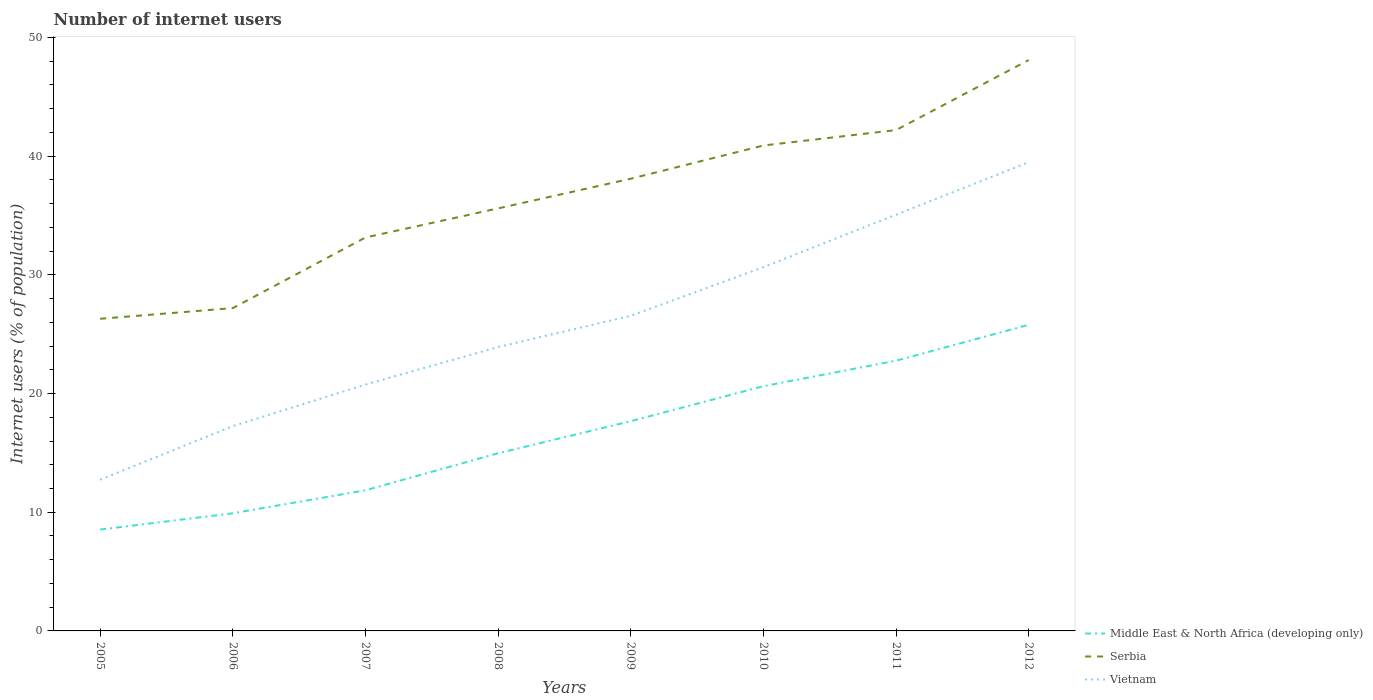Across all years, what is the maximum number of internet users in Middle East & North Africa (developing only)?
Your answer should be compact. 8.54. What is the total number of internet users in Middle East & North Africa (developing only) in the graph?
Offer a very short reply. -17.25. What is the difference between the highest and the second highest number of internet users in Middle East & North Africa (developing only)?
Your answer should be very brief. 17.25. What is the difference between the highest and the lowest number of internet users in Vietnam?
Provide a short and direct response. 4. Is the number of internet users in Vietnam strictly greater than the number of internet users in Middle East & North Africa (developing only) over the years?
Keep it short and to the point. No. How many lines are there?
Your answer should be compact. 3. How many years are there in the graph?
Ensure brevity in your answer.  8. What is the difference between two consecutive major ticks on the Y-axis?
Provide a short and direct response. 10. Does the graph contain any zero values?
Provide a short and direct response. No. Does the graph contain grids?
Give a very brief answer. No. What is the title of the graph?
Ensure brevity in your answer.  Number of internet users. Does "Bulgaria" appear as one of the legend labels in the graph?
Provide a succinct answer. No. What is the label or title of the X-axis?
Keep it short and to the point. Years. What is the label or title of the Y-axis?
Ensure brevity in your answer.  Internet users (% of population). What is the Internet users (% of population) of Middle East & North Africa (developing only) in 2005?
Your answer should be very brief. 8.54. What is the Internet users (% of population) in Serbia in 2005?
Provide a short and direct response. 26.3. What is the Internet users (% of population) in Vietnam in 2005?
Your answer should be compact. 12.74. What is the Internet users (% of population) of Middle East & North Africa (developing only) in 2006?
Keep it short and to the point. 9.91. What is the Internet users (% of population) in Serbia in 2006?
Your answer should be compact. 27.2. What is the Internet users (% of population) of Vietnam in 2006?
Provide a short and direct response. 17.25. What is the Internet users (% of population) in Middle East & North Africa (developing only) in 2007?
Offer a terse response. 11.85. What is the Internet users (% of population) of Serbia in 2007?
Offer a terse response. 33.15. What is the Internet users (% of population) of Vietnam in 2007?
Keep it short and to the point. 20.76. What is the Internet users (% of population) in Middle East & North Africa (developing only) in 2008?
Your response must be concise. 14.97. What is the Internet users (% of population) in Serbia in 2008?
Your response must be concise. 35.6. What is the Internet users (% of population) in Vietnam in 2008?
Your answer should be very brief. 23.92. What is the Internet users (% of population) in Middle East & North Africa (developing only) in 2009?
Ensure brevity in your answer.  17.67. What is the Internet users (% of population) in Serbia in 2009?
Offer a terse response. 38.1. What is the Internet users (% of population) of Vietnam in 2009?
Offer a terse response. 26.55. What is the Internet users (% of population) of Middle East & North Africa (developing only) in 2010?
Provide a short and direct response. 20.62. What is the Internet users (% of population) of Serbia in 2010?
Your response must be concise. 40.9. What is the Internet users (% of population) of Vietnam in 2010?
Your answer should be very brief. 30.65. What is the Internet users (% of population) in Middle East & North Africa (developing only) in 2011?
Offer a very short reply. 22.77. What is the Internet users (% of population) of Serbia in 2011?
Provide a short and direct response. 42.2. What is the Internet users (% of population) of Vietnam in 2011?
Offer a very short reply. 35.07. What is the Internet users (% of population) in Middle East & North Africa (developing only) in 2012?
Offer a terse response. 25.79. What is the Internet users (% of population) of Serbia in 2012?
Give a very brief answer. 48.1. What is the Internet users (% of population) in Vietnam in 2012?
Your answer should be very brief. 39.49. Across all years, what is the maximum Internet users (% of population) in Middle East & North Africa (developing only)?
Your answer should be very brief. 25.79. Across all years, what is the maximum Internet users (% of population) in Serbia?
Offer a terse response. 48.1. Across all years, what is the maximum Internet users (% of population) of Vietnam?
Provide a short and direct response. 39.49. Across all years, what is the minimum Internet users (% of population) in Middle East & North Africa (developing only)?
Your answer should be compact. 8.54. Across all years, what is the minimum Internet users (% of population) of Serbia?
Provide a short and direct response. 26.3. Across all years, what is the minimum Internet users (% of population) of Vietnam?
Provide a short and direct response. 12.74. What is the total Internet users (% of population) of Middle East & North Africa (developing only) in the graph?
Give a very brief answer. 132.12. What is the total Internet users (% of population) of Serbia in the graph?
Your answer should be very brief. 291.55. What is the total Internet users (% of population) in Vietnam in the graph?
Offer a terse response. 206.43. What is the difference between the Internet users (% of population) of Middle East & North Africa (developing only) in 2005 and that in 2006?
Offer a very short reply. -1.37. What is the difference between the Internet users (% of population) of Serbia in 2005 and that in 2006?
Your answer should be very brief. -0.9. What is the difference between the Internet users (% of population) in Vietnam in 2005 and that in 2006?
Keep it short and to the point. -4.51. What is the difference between the Internet users (% of population) in Middle East & North Africa (developing only) in 2005 and that in 2007?
Keep it short and to the point. -3.31. What is the difference between the Internet users (% of population) in Serbia in 2005 and that in 2007?
Provide a short and direct response. -6.85. What is the difference between the Internet users (% of population) of Vietnam in 2005 and that in 2007?
Keep it short and to the point. -8.02. What is the difference between the Internet users (% of population) in Middle East & North Africa (developing only) in 2005 and that in 2008?
Your answer should be compact. -6.43. What is the difference between the Internet users (% of population) of Serbia in 2005 and that in 2008?
Make the answer very short. -9.3. What is the difference between the Internet users (% of population) of Vietnam in 2005 and that in 2008?
Ensure brevity in your answer.  -11.18. What is the difference between the Internet users (% of population) of Middle East & North Africa (developing only) in 2005 and that in 2009?
Offer a very short reply. -9.13. What is the difference between the Internet users (% of population) in Serbia in 2005 and that in 2009?
Ensure brevity in your answer.  -11.8. What is the difference between the Internet users (% of population) in Vietnam in 2005 and that in 2009?
Make the answer very short. -13.81. What is the difference between the Internet users (% of population) of Middle East & North Africa (developing only) in 2005 and that in 2010?
Keep it short and to the point. -12.08. What is the difference between the Internet users (% of population) of Serbia in 2005 and that in 2010?
Offer a very short reply. -14.6. What is the difference between the Internet users (% of population) in Vietnam in 2005 and that in 2010?
Your answer should be very brief. -17.91. What is the difference between the Internet users (% of population) in Middle East & North Africa (developing only) in 2005 and that in 2011?
Your answer should be very brief. -14.23. What is the difference between the Internet users (% of population) of Serbia in 2005 and that in 2011?
Offer a very short reply. -15.9. What is the difference between the Internet users (% of population) of Vietnam in 2005 and that in 2011?
Your answer should be very brief. -22.33. What is the difference between the Internet users (% of population) of Middle East & North Africa (developing only) in 2005 and that in 2012?
Your answer should be compact. -17.25. What is the difference between the Internet users (% of population) of Serbia in 2005 and that in 2012?
Offer a terse response. -21.8. What is the difference between the Internet users (% of population) of Vietnam in 2005 and that in 2012?
Offer a very short reply. -26.75. What is the difference between the Internet users (% of population) of Middle East & North Africa (developing only) in 2006 and that in 2007?
Offer a terse response. -1.94. What is the difference between the Internet users (% of population) of Serbia in 2006 and that in 2007?
Provide a short and direct response. -5.95. What is the difference between the Internet users (% of population) in Vietnam in 2006 and that in 2007?
Your response must be concise. -3.5. What is the difference between the Internet users (% of population) in Middle East & North Africa (developing only) in 2006 and that in 2008?
Keep it short and to the point. -5.05. What is the difference between the Internet users (% of population) in Serbia in 2006 and that in 2008?
Offer a very short reply. -8.4. What is the difference between the Internet users (% of population) in Vietnam in 2006 and that in 2008?
Your answer should be compact. -6.67. What is the difference between the Internet users (% of population) of Middle East & North Africa (developing only) in 2006 and that in 2009?
Make the answer very short. -7.76. What is the difference between the Internet users (% of population) in Serbia in 2006 and that in 2009?
Make the answer very short. -10.9. What is the difference between the Internet users (% of population) of Vietnam in 2006 and that in 2009?
Provide a short and direct response. -9.3. What is the difference between the Internet users (% of population) in Middle East & North Africa (developing only) in 2006 and that in 2010?
Offer a terse response. -10.71. What is the difference between the Internet users (% of population) in Serbia in 2006 and that in 2010?
Your answer should be very brief. -13.7. What is the difference between the Internet users (% of population) of Vietnam in 2006 and that in 2010?
Your answer should be compact. -13.4. What is the difference between the Internet users (% of population) in Middle East & North Africa (developing only) in 2006 and that in 2011?
Ensure brevity in your answer.  -12.85. What is the difference between the Internet users (% of population) of Vietnam in 2006 and that in 2011?
Your answer should be very brief. -17.82. What is the difference between the Internet users (% of population) in Middle East & North Africa (developing only) in 2006 and that in 2012?
Make the answer very short. -15.88. What is the difference between the Internet users (% of population) in Serbia in 2006 and that in 2012?
Offer a very short reply. -20.9. What is the difference between the Internet users (% of population) in Vietnam in 2006 and that in 2012?
Give a very brief answer. -22.24. What is the difference between the Internet users (% of population) in Middle East & North Africa (developing only) in 2007 and that in 2008?
Give a very brief answer. -3.12. What is the difference between the Internet users (% of population) of Serbia in 2007 and that in 2008?
Give a very brief answer. -2.45. What is the difference between the Internet users (% of population) in Vietnam in 2007 and that in 2008?
Your response must be concise. -3.16. What is the difference between the Internet users (% of population) of Middle East & North Africa (developing only) in 2007 and that in 2009?
Provide a short and direct response. -5.82. What is the difference between the Internet users (% of population) of Serbia in 2007 and that in 2009?
Offer a terse response. -4.95. What is the difference between the Internet users (% of population) of Vietnam in 2007 and that in 2009?
Give a very brief answer. -5.79. What is the difference between the Internet users (% of population) in Middle East & North Africa (developing only) in 2007 and that in 2010?
Make the answer very short. -8.77. What is the difference between the Internet users (% of population) in Serbia in 2007 and that in 2010?
Your answer should be very brief. -7.75. What is the difference between the Internet users (% of population) in Vietnam in 2007 and that in 2010?
Your response must be concise. -9.89. What is the difference between the Internet users (% of population) of Middle East & North Africa (developing only) in 2007 and that in 2011?
Keep it short and to the point. -10.92. What is the difference between the Internet users (% of population) in Serbia in 2007 and that in 2011?
Your answer should be compact. -9.05. What is the difference between the Internet users (% of population) of Vietnam in 2007 and that in 2011?
Your response must be concise. -14.31. What is the difference between the Internet users (% of population) in Middle East & North Africa (developing only) in 2007 and that in 2012?
Offer a terse response. -13.94. What is the difference between the Internet users (% of population) in Serbia in 2007 and that in 2012?
Give a very brief answer. -14.95. What is the difference between the Internet users (% of population) of Vietnam in 2007 and that in 2012?
Provide a short and direct response. -18.73. What is the difference between the Internet users (% of population) in Middle East & North Africa (developing only) in 2008 and that in 2009?
Your answer should be very brief. -2.7. What is the difference between the Internet users (% of population) in Vietnam in 2008 and that in 2009?
Your answer should be compact. -2.63. What is the difference between the Internet users (% of population) in Middle East & North Africa (developing only) in 2008 and that in 2010?
Offer a very short reply. -5.65. What is the difference between the Internet users (% of population) of Vietnam in 2008 and that in 2010?
Ensure brevity in your answer.  -6.73. What is the difference between the Internet users (% of population) in Middle East & North Africa (developing only) in 2008 and that in 2011?
Ensure brevity in your answer.  -7.8. What is the difference between the Internet users (% of population) in Serbia in 2008 and that in 2011?
Make the answer very short. -6.6. What is the difference between the Internet users (% of population) of Vietnam in 2008 and that in 2011?
Offer a terse response. -11.15. What is the difference between the Internet users (% of population) in Middle East & North Africa (developing only) in 2008 and that in 2012?
Provide a succinct answer. -10.83. What is the difference between the Internet users (% of population) of Vietnam in 2008 and that in 2012?
Your answer should be compact. -15.57. What is the difference between the Internet users (% of population) in Middle East & North Africa (developing only) in 2009 and that in 2010?
Your answer should be compact. -2.95. What is the difference between the Internet users (% of population) of Middle East & North Africa (developing only) in 2009 and that in 2011?
Your answer should be very brief. -5.1. What is the difference between the Internet users (% of population) in Vietnam in 2009 and that in 2011?
Ensure brevity in your answer.  -8.52. What is the difference between the Internet users (% of population) in Middle East & North Africa (developing only) in 2009 and that in 2012?
Give a very brief answer. -8.12. What is the difference between the Internet users (% of population) in Serbia in 2009 and that in 2012?
Provide a short and direct response. -10. What is the difference between the Internet users (% of population) in Vietnam in 2009 and that in 2012?
Provide a short and direct response. -12.94. What is the difference between the Internet users (% of population) of Middle East & North Africa (developing only) in 2010 and that in 2011?
Make the answer very short. -2.15. What is the difference between the Internet users (% of population) in Vietnam in 2010 and that in 2011?
Your answer should be very brief. -4.42. What is the difference between the Internet users (% of population) in Middle East & North Africa (developing only) in 2010 and that in 2012?
Offer a very short reply. -5.17. What is the difference between the Internet users (% of population) in Serbia in 2010 and that in 2012?
Your response must be concise. -7.2. What is the difference between the Internet users (% of population) in Vietnam in 2010 and that in 2012?
Ensure brevity in your answer.  -8.84. What is the difference between the Internet users (% of population) of Middle East & North Africa (developing only) in 2011 and that in 2012?
Your answer should be very brief. -3.03. What is the difference between the Internet users (% of population) in Serbia in 2011 and that in 2012?
Offer a terse response. -5.9. What is the difference between the Internet users (% of population) of Vietnam in 2011 and that in 2012?
Your response must be concise. -4.42. What is the difference between the Internet users (% of population) in Middle East & North Africa (developing only) in 2005 and the Internet users (% of population) in Serbia in 2006?
Offer a very short reply. -18.66. What is the difference between the Internet users (% of population) in Middle East & North Africa (developing only) in 2005 and the Internet users (% of population) in Vietnam in 2006?
Ensure brevity in your answer.  -8.72. What is the difference between the Internet users (% of population) in Serbia in 2005 and the Internet users (% of population) in Vietnam in 2006?
Your response must be concise. 9.05. What is the difference between the Internet users (% of population) in Middle East & North Africa (developing only) in 2005 and the Internet users (% of population) in Serbia in 2007?
Provide a succinct answer. -24.61. What is the difference between the Internet users (% of population) of Middle East & North Africa (developing only) in 2005 and the Internet users (% of population) of Vietnam in 2007?
Give a very brief answer. -12.22. What is the difference between the Internet users (% of population) of Serbia in 2005 and the Internet users (% of population) of Vietnam in 2007?
Provide a succinct answer. 5.54. What is the difference between the Internet users (% of population) of Middle East & North Africa (developing only) in 2005 and the Internet users (% of population) of Serbia in 2008?
Provide a succinct answer. -27.06. What is the difference between the Internet users (% of population) in Middle East & North Africa (developing only) in 2005 and the Internet users (% of population) in Vietnam in 2008?
Give a very brief answer. -15.38. What is the difference between the Internet users (% of population) in Serbia in 2005 and the Internet users (% of population) in Vietnam in 2008?
Your response must be concise. 2.38. What is the difference between the Internet users (% of population) of Middle East & North Africa (developing only) in 2005 and the Internet users (% of population) of Serbia in 2009?
Offer a very short reply. -29.56. What is the difference between the Internet users (% of population) of Middle East & North Africa (developing only) in 2005 and the Internet users (% of population) of Vietnam in 2009?
Provide a short and direct response. -18.01. What is the difference between the Internet users (% of population) in Serbia in 2005 and the Internet users (% of population) in Vietnam in 2009?
Give a very brief answer. -0.25. What is the difference between the Internet users (% of population) in Middle East & North Africa (developing only) in 2005 and the Internet users (% of population) in Serbia in 2010?
Make the answer very short. -32.36. What is the difference between the Internet users (% of population) in Middle East & North Africa (developing only) in 2005 and the Internet users (% of population) in Vietnam in 2010?
Make the answer very short. -22.11. What is the difference between the Internet users (% of population) in Serbia in 2005 and the Internet users (% of population) in Vietnam in 2010?
Ensure brevity in your answer.  -4.35. What is the difference between the Internet users (% of population) of Middle East & North Africa (developing only) in 2005 and the Internet users (% of population) of Serbia in 2011?
Give a very brief answer. -33.66. What is the difference between the Internet users (% of population) in Middle East & North Africa (developing only) in 2005 and the Internet users (% of population) in Vietnam in 2011?
Offer a very short reply. -26.53. What is the difference between the Internet users (% of population) of Serbia in 2005 and the Internet users (% of population) of Vietnam in 2011?
Ensure brevity in your answer.  -8.77. What is the difference between the Internet users (% of population) in Middle East & North Africa (developing only) in 2005 and the Internet users (% of population) in Serbia in 2012?
Your answer should be very brief. -39.56. What is the difference between the Internet users (% of population) in Middle East & North Africa (developing only) in 2005 and the Internet users (% of population) in Vietnam in 2012?
Your response must be concise. -30.95. What is the difference between the Internet users (% of population) in Serbia in 2005 and the Internet users (% of population) in Vietnam in 2012?
Keep it short and to the point. -13.19. What is the difference between the Internet users (% of population) in Middle East & North Africa (developing only) in 2006 and the Internet users (% of population) in Serbia in 2007?
Provide a succinct answer. -23.24. What is the difference between the Internet users (% of population) in Middle East & North Africa (developing only) in 2006 and the Internet users (% of population) in Vietnam in 2007?
Your response must be concise. -10.84. What is the difference between the Internet users (% of population) in Serbia in 2006 and the Internet users (% of population) in Vietnam in 2007?
Offer a very short reply. 6.44. What is the difference between the Internet users (% of population) of Middle East & North Africa (developing only) in 2006 and the Internet users (% of population) of Serbia in 2008?
Your response must be concise. -25.69. What is the difference between the Internet users (% of population) in Middle East & North Africa (developing only) in 2006 and the Internet users (% of population) in Vietnam in 2008?
Your answer should be compact. -14.01. What is the difference between the Internet users (% of population) of Serbia in 2006 and the Internet users (% of population) of Vietnam in 2008?
Give a very brief answer. 3.28. What is the difference between the Internet users (% of population) in Middle East & North Africa (developing only) in 2006 and the Internet users (% of population) in Serbia in 2009?
Ensure brevity in your answer.  -28.19. What is the difference between the Internet users (% of population) of Middle East & North Africa (developing only) in 2006 and the Internet users (% of population) of Vietnam in 2009?
Keep it short and to the point. -16.64. What is the difference between the Internet users (% of population) in Serbia in 2006 and the Internet users (% of population) in Vietnam in 2009?
Ensure brevity in your answer.  0.65. What is the difference between the Internet users (% of population) in Middle East & North Africa (developing only) in 2006 and the Internet users (% of population) in Serbia in 2010?
Offer a terse response. -30.99. What is the difference between the Internet users (% of population) of Middle East & North Africa (developing only) in 2006 and the Internet users (% of population) of Vietnam in 2010?
Keep it short and to the point. -20.74. What is the difference between the Internet users (% of population) of Serbia in 2006 and the Internet users (% of population) of Vietnam in 2010?
Your answer should be very brief. -3.45. What is the difference between the Internet users (% of population) in Middle East & North Africa (developing only) in 2006 and the Internet users (% of population) in Serbia in 2011?
Offer a very short reply. -32.29. What is the difference between the Internet users (% of population) of Middle East & North Africa (developing only) in 2006 and the Internet users (% of population) of Vietnam in 2011?
Give a very brief answer. -25.16. What is the difference between the Internet users (% of population) of Serbia in 2006 and the Internet users (% of population) of Vietnam in 2011?
Ensure brevity in your answer.  -7.87. What is the difference between the Internet users (% of population) of Middle East & North Africa (developing only) in 2006 and the Internet users (% of population) of Serbia in 2012?
Your answer should be compact. -38.19. What is the difference between the Internet users (% of population) in Middle East & North Africa (developing only) in 2006 and the Internet users (% of population) in Vietnam in 2012?
Provide a succinct answer. -29.58. What is the difference between the Internet users (% of population) of Serbia in 2006 and the Internet users (% of population) of Vietnam in 2012?
Offer a terse response. -12.29. What is the difference between the Internet users (% of population) in Middle East & North Africa (developing only) in 2007 and the Internet users (% of population) in Serbia in 2008?
Provide a succinct answer. -23.75. What is the difference between the Internet users (% of population) in Middle East & North Africa (developing only) in 2007 and the Internet users (% of population) in Vietnam in 2008?
Offer a very short reply. -12.07. What is the difference between the Internet users (% of population) of Serbia in 2007 and the Internet users (% of population) of Vietnam in 2008?
Ensure brevity in your answer.  9.23. What is the difference between the Internet users (% of population) in Middle East & North Africa (developing only) in 2007 and the Internet users (% of population) in Serbia in 2009?
Offer a terse response. -26.25. What is the difference between the Internet users (% of population) of Middle East & North Africa (developing only) in 2007 and the Internet users (% of population) of Vietnam in 2009?
Keep it short and to the point. -14.7. What is the difference between the Internet users (% of population) in Serbia in 2007 and the Internet users (% of population) in Vietnam in 2009?
Offer a terse response. 6.6. What is the difference between the Internet users (% of population) in Middle East & North Africa (developing only) in 2007 and the Internet users (% of population) in Serbia in 2010?
Your answer should be very brief. -29.05. What is the difference between the Internet users (% of population) of Middle East & North Africa (developing only) in 2007 and the Internet users (% of population) of Vietnam in 2010?
Offer a very short reply. -18.8. What is the difference between the Internet users (% of population) of Serbia in 2007 and the Internet users (% of population) of Vietnam in 2010?
Offer a terse response. 2.5. What is the difference between the Internet users (% of population) of Middle East & North Africa (developing only) in 2007 and the Internet users (% of population) of Serbia in 2011?
Offer a very short reply. -30.35. What is the difference between the Internet users (% of population) in Middle East & North Africa (developing only) in 2007 and the Internet users (% of population) in Vietnam in 2011?
Keep it short and to the point. -23.22. What is the difference between the Internet users (% of population) of Serbia in 2007 and the Internet users (% of population) of Vietnam in 2011?
Make the answer very short. -1.92. What is the difference between the Internet users (% of population) in Middle East & North Africa (developing only) in 2007 and the Internet users (% of population) in Serbia in 2012?
Your answer should be compact. -36.25. What is the difference between the Internet users (% of population) of Middle East & North Africa (developing only) in 2007 and the Internet users (% of population) of Vietnam in 2012?
Give a very brief answer. -27.64. What is the difference between the Internet users (% of population) in Serbia in 2007 and the Internet users (% of population) in Vietnam in 2012?
Your response must be concise. -6.34. What is the difference between the Internet users (% of population) of Middle East & North Africa (developing only) in 2008 and the Internet users (% of population) of Serbia in 2009?
Keep it short and to the point. -23.13. What is the difference between the Internet users (% of population) of Middle East & North Africa (developing only) in 2008 and the Internet users (% of population) of Vietnam in 2009?
Provide a short and direct response. -11.58. What is the difference between the Internet users (% of population) of Serbia in 2008 and the Internet users (% of population) of Vietnam in 2009?
Provide a succinct answer. 9.05. What is the difference between the Internet users (% of population) in Middle East & North Africa (developing only) in 2008 and the Internet users (% of population) in Serbia in 2010?
Keep it short and to the point. -25.93. What is the difference between the Internet users (% of population) of Middle East & North Africa (developing only) in 2008 and the Internet users (% of population) of Vietnam in 2010?
Make the answer very short. -15.68. What is the difference between the Internet users (% of population) in Serbia in 2008 and the Internet users (% of population) in Vietnam in 2010?
Offer a very short reply. 4.95. What is the difference between the Internet users (% of population) in Middle East & North Africa (developing only) in 2008 and the Internet users (% of population) in Serbia in 2011?
Offer a terse response. -27.23. What is the difference between the Internet users (% of population) in Middle East & North Africa (developing only) in 2008 and the Internet users (% of population) in Vietnam in 2011?
Keep it short and to the point. -20.1. What is the difference between the Internet users (% of population) of Serbia in 2008 and the Internet users (% of population) of Vietnam in 2011?
Give a very brief answer. 0.53. What is the difference between the Internet users (% of population) of Middle East & North Africa (developing only) in 2008 and the Internet users (% of population) of Serbia in 2012?
Provide a succinct answer. -33.13. What is the difference between the Internet users (% of population) in Middle East & North Africa (developing only) in 2008 and the Internet users (% of population) in Vietnam in 2012?
Ensure brevity in your answer.  -24.52. What is the difference between the Internet users (% of population) of Serbia in 2008 and the Internet users (% of population) of Vietnam in 2012?
Keep it short and to the point. -3.89. What is the difference between the Internet users (% of population) of Middle East & North Africa (developing only) in 2009 and the Internet users (% of population) of Serbia in 2010?
Your response must be concise. -23.23. What is the difference between the Internet users (% of population) of Middle East & North Africa (developing only) in 2009 and the Internet users (% of population) of Vietnam in 2010?
Your response must be concise. -12.98. What is the difference between the Internet users (% of population) in Serbia in 2009 and the Internet users (% of population) in Vietnam in 2010?
Provide a short and direct response. 7.45. What is the difference between the Internet users (% of population) of Middle East & North Africa (developing only) in 2009 and the Internet users (% of population) of Serbia in 2011?
Offer a terse response. -24.53. What is the difference between the Internet users (% of population) in Middle East & North Africa (developing only) in 2009 and the Internet users (% of population) in Vietnam in 2011?
Your answer should be very brief. -17.4. What is the difference between the Internet users (% of population) of Serbia in 2009 and the Internet users (% of population) of Vietnam in 2011?
Ensure brevity in your answer.  3.03. What is the difference between the Internet users (% of population) in Middle East & North Africa (developing only) in 2009 and the Internet users (% of population) in Serbia in 2012?
Give a very brief answer. -30.43. What is the difference between the Internet users (% of population) in Middle East & North Africa (developing only) in 2009 and the Internet users (% of population) in Vietnam in 2012?
Provide a short and direct response. -21.82. What is the difference between the Internet users (% of population) of Serbia in 2009 and the Internet users (% of population) of Vietnam in 2012?
Your answer should be very brief. -1.39. What is the difference between the Internet users (% of population) of Middle East & North Africa (developing only) in 2010 and the Internet users (% of population) of Serbia in 2011?
Ensure brevity in your answer.  -21.58. What is the difference between the Internet users (% of population) of Middle East & North Africa (developing only) in 2010 and the Internet users (% of population) of Vietnam in 2011?
Keep it short and to the point. -14.45. What is the difference between the Internet users (% of population) in Serbia in 2010 and the Internet users (% of population) in Vietnam in 2011?
Offer a terse response. 5.83. What is the difference between the Internet users (% of population) in Middle East & North Africa (developing only) in 2010 and the Internet users (% of population) in Serbia in 2012?
Your response must be concise. -27.48. What is the difference between the Internet users (% of population) of Middle East & North Africa (developing only) in 2010 and the Internet users (% of population) of Vietnam in 2012?
Ensure brevity in your answer.  -18.87. What is the difference between the Internet users (% of population) in Serbia in 2010 and the Internet users (% of population) in Vietnam in 2012?
Provide a short and direct response. 1.41. What is the difference between the Internet users (% of population) in Middle East & North Africa (developing only) in 2011 and the Internet users (% of population) in Serbia in 2012?
Your response must be concise. -25.33. What is the difference between the Internet users (% of population) in Middle East & North Africa (developing only) in 2011 and the Internet users (% of population) in Vietnam in 2012?
Keep it short and to the point. -16.72. What is the difference between the Internet users (% of population) in Serbia in 2011 and the Internet users (% of population) in Vietnam in 2012?
Give a very brief answer. 2.71. What is the average Internet users (% of population) of Middle East & North Africa (developing only) per year?
Your response must be concise. 16.51. What is the average Internet users (% of population) in Serbia per year?
Your answer should be very brief. 36.44. What is the average Internet users (% of population) of Vietnam per year?
Your answer should be very brief. 25.8. In the year 2005, what is the difference between the Internet users (% of population) of Middle East & North Africa (developing only) and Internet users (% of population) of Serbia?
Your answer should be compact. -17.76. In the year 2005, what is the difference between the Internet users (% of population) of Middle East & North Africa (developing only) and Internet users (% of population) of Vietnam?
Ensure brevity in your answer.  -4.2. In the year 2005, what is the difference between the Internet users (% of population) of Serbia and Internet users (% of population) of Vietnam?
Offer a very short reply. 13.56. In the year 2006, what is the difference between the Internet users (% of population) in Middle East & North Africa (developing only) and Internet users (% of population) in Serbia?
Give a very brief answer. -17.29. In the year 2006, what is the difference between the Internet users (% of population) in Middle East & North Africa (developing only) and Internet users (% of population) in Vietnam?
Offer a very short reply. -7.34. In the year 2006, what is the difference between the Internet users (% of population) of Serbia and Internet users (% of population) of Vietnam?
Make the answer very short. 9.95. In the year 2007, what is the difference between the Internet users (% of population) in Middle East & North Africa (developing only) and Internet users (% of population) in Serbia?
Your answer should be compact. -21.3. In the year 2007, what is the difference between the Internet users (% of population) of Middle East & North Africa (developing only) and Internet users (% of population) of Vietnam?
Give a very brief answer. -8.91. In the year 2007, what is the difference between the Internet users (% of population) of Serbia and Internet users (% of population) of Vietnam?
Provide a succinct answer. 12.39. In the year 2008, what is the difference between the Internet users (% of population) in Middle East & North Africa (developing only) and Internet users (% of population) in Serbia?
Keep it short and to the point. -20.63. In the year 2008, what is the difference between the Internet users (% of population) of Middle East & North Africa (developing only) and Internet users (% of population) of Vietnam?
Your response must be concise. -8.95. In the year 2008, what is the difference between the Internet users (% of population) of Serbia and Internet users (% of population) of Vietnam?
Your answer should be very brief. 11.68. In the year 2009, what is the difference between the Internet users (% of population) in Middle East & North Africa (developing only) and Internet users (% of population) in Serbia?
Offer a very short reply. -20.43. In the year 2009, what is the difference between the Internet users (% of population) in Middle East & North Africa (developing only) and Internet users (% of population) in Vietnam?
Provide a short and direct response. -8.88. In the year 2009, what is the difference between the Internet users (% of population) in Serbia and Internet users (% of population) in Vietnam?
Provide a short and direct response. 11.55. In the year 2010, what is the difference between the Internet users (% of population) of Middle East & North Africa (developing only) and Internet users (% of population) of Serbia?
Your answer should be very brief. -20.28. In the year 2010, what is the difference between the Internet users (% of population) in Middle East & North Africa (developing only) and Internet users (% of population) in Vietnam?
Offer a very short reply. -10.03. In the year 2010, what is the difference between the Internet users (% of population) in Serbia and Internet users (% of population) in Vietnam?
Your answer should be compact. 10.25. In the year 2011, what is the difference between the Internet users (% of population) in Middle East & North Africa (developing only) and Internet users (% of population) in Serbia?
Ensure brevity in your answer.  -19.43. In the year 2011, what is the difference between the Internet users (% of population) of Middle East & North Africa (developing only) and Internet users (% of population) of Vietnam?
Give a very brief answer. -12.3. In the year 2011, what is the difference between the Internet users (% of population) in Serbia and Internet users (% of population) in Vietnam?
Offer a terse response. 7.13. In the year 2012, what is the difference between the Internet users (% of population) in Middle East & North Africa (developing only) and Internet users (% of population) in Serbia?
Provide a succinct answer. -22.31. In the year 2012, what is the difference between the Internet users (% of population) in Middle East & North Africa (developing only) and Internet users (% of population) in Vietnam?
Give a very brief answer. -13.7. In the year 2012, what is the difference between the Internet users (% of population) of Serbia and Internet users (% of population) of Vietnam?
Offer a very short reply. 8.61. What is the ratio of the Internet users (% of population) of Middle East & North Africa (developing only) in 2005 to that in 2006?
Your answer should be compact. 0.86. What is the ratio of the Internet users (% of population) in Serbia in 2005 to that in 2006?
Provide a succinct answer. 0.97. What is the ratio of the Internet users (% of population) of Vietnam in 2005 to that in 2006?
Your answer should be very brief. 0.74. What is the ratio of the Internet users (% of population) in Middle East & North Africa (developing only) in 2005 to that in 2007?
Provide a short and direct response. 0.72. What is the ratio of the Internet users (% of population) of Serbia in 2005 to that in 2007?
Offer a terse response. 0.79. What is the ratio of the Internet users (% of population) of Vietnam in 2005 to that in 2007?
Make the answer very short. 0.61. What is the ratio of the Internet users (% of population) in Middle East & North Africa (developing only) in 2005 to that in 2008?
Provide a succinct answer. 0.57. What is the ratio of the Internet users (% of population) of Serbia in 2005 to that in 2008?
Offer a very short reply. 0.74. What is the ratio of the Internet users (% of population) in Vietnam in 2005 to that in 2008?
Provide a short and direct response. 0.53. What is the ratio of the Internet users (% of population) in Middle East & North Africa (developing only) in 2005 to that in 2009?
Offer a very short reply. 0.48. What is the ratio of the Internet users (% of population) of Serbia in 2005 to that in 2009?
Your answer should be compact. 0.69. What is the ratio of the Internet users (% of population) in Vietnam in 2005 to that in 2009?
Offer a terse response. 0.48. What is the ratio of the Internet users (% of population) of Middle East & North Africa (developing only) in 2005 to that in 2010?
Your answer should be compact. 0.41. What is the ratio of the Internet users (% of population) in Serbia in 2005 to that in 2010?
Make the answer very short. 0.64. What is the ratio of the Internet users (% of population) of Vietnam in 2005 to that in 2010?
Ensure brevity in your answer.  0.42. What is the ratio of the Internet users (% of population) of Middle East & North Africa (developing only) in 2005 to that in 2011?
Offer a terse response. 0.38. What is the ratio of the Internet users (% of population) of Serbia in 2005 to that in 2011?
Provide a succinct answer. 0.62. What is the ratio of the Internet users (% of population) in Vietnam in 2005 to that in 2011?
Offer a very short reply. 0.36. What is the ratio of the Internet users (% of population) of Middle East & North Africa (developing only) in 2005 to that in 2012?
Your response must be concise. 0.33. What is the ratio of the Internet users (% of population) of Serbia in 2005 to that in 2012?
Your answer should be very brief. 0.55. What is the ratio of the Internet users (% of population) of Vietnam in 2005 to that in 2012?
Provide a short and direct response. 0.32. What is the ratio of the Internet users (% of population) in Middle East & North Africa (developing only) in 2006 to that in 2007?
Keep it short and to the point. 0.84. What is the ratio of the Internet users (% of population) of Serbia in 2006 to that in 2007?
Your response must be concise. 0.82. What is the ratio of the Internet users (% of population) in Vietnam in 2006 to that in 2007?
Offer a very short reply. 0.83. What is the ratio of the Internet users (% of population) of Middle East & North Africa (developing only) in 2006 to that in 2008?
Keep it short and to the point. 0.66. What is the ratio of the Internet users (% of population) of Serbia in 2006 to that in 2008?
Your answer should be very brief. 0.76. What is the ratio of the Internet users (% of population) of Vietnam in 2006 to that in 2008?
Your answer should be very brief. 0.72. What is the ratio of the Internet users (% of population) of Middle East & North Africa (developing only) in 2006 to that in 2009?
Ensure brevity in your answer.  0.56. What is the ratio of the Internet users (% of population) of Serbia in 2006 to that in 2009?
Provide a short and direct response. 0.71. What is the ratio of the Internet users (% of population) of Vietnam in 2006 to that in 2009?
Provide a short and direct response. 0.65. What is the ratio of the Internet users (% of population) of Middle East & North Africa (developing only) in 2006 to that in 2010?
Your answer should be very brief. 0.48. What is the ratio of the Internet users (% of population) in Serbia in 2006 to that in 2010?
Your response must be concise. 0.67. What is the ratio of the Internet users (% of population) of Vietnam in 2006 to that in 2010?
Ensure brevity in your answer.  0.56. What is the ratio of the Internet users (% of population) in Middle East & North Africa (developing only) in 2006 to that in 2011?
Your answer should be compact. 0.44. What is the ratio of the Internet users (% of population) in Serbia in 2006 to that in 2011?
Provide a succinct answer. 0.64. What is the ratio of the Internet users (% of population) of Vietnam in 2006 to that in 2011?
Provide a short and direct response. 0.49. What is the ratio of the Internet users (% of population) of Middle East & North Africa (developing only) in 2006 to that in 2012?
Offer a very short reply. 0.38. What is the ratio of the Internet users (% of population) in Serbia in 2006 to that in 2012?
Give a very brief answer. 0.57. What is the ratio of the Internet users (% of population) in Vietnam in 2006 to that in 2012?
Provide a succinct answer. 0.44. What is the ratio of the Internet users (% of population) of Middle East & North Africa (developing only) in 2007 to that in 2008?
Provide a short and direct response. 0.79. What is the ratio of the Internet users (% of population) in Serbia in 2007 to that in 2008?
Give a very brief answer. 0.93. What is the ratio of the Internet users (% of population) of Vietnam in 2007 to that in 2008?
Your answer should be compact. 0.87. What is the ratio of the Internet users (% of population) of Middle East & North Africa (developing only) in 2007 to that in 2009?
Your answer should be very brief. 0.67. What is the ratio of the Internet users (% of population) in Serbia in 2007 to that in 2009?
Ensure brevity in your answer.  0.87. What is the ratio of the Internet users (% of population) of Vietnam in 2007 to that in 2009?
Your answer should be compact. 0.78. What is the ratio of the Internet users (% of population) of Middle East & North Africa (developing only) in 2007 to that in 2010?
Your response must be concise. 0.57. What is the ratio of the Internet users (% of population) in Serbia in 2007 to that in 2010?
Provide a succinct answer. 0.81. What is the ratio of the Internet users (% of population) of Vietnam in 2007 to that in 2010?
Ensure brevity in your answer.  0.68. What is the ratio of the Internet users (% of population) of Middle East & North Africa (developing only) in 2007 to that in 2011?
Offer a very short reply. 0.52. What is the ratio of the Internet users (% of population) in Serbia in 2007 to that in 2011?
Provide a succinct answer. 0.79. What is the ratio of the Internet users (% of population) of Vietnam in 2007 to that in 2011?
Offer a very short reply. 0.59. What is the ratio of the Internet users (% of population) of Middle East & North Africa (developing only) in 2007 to that in 2012?
Your answer should be compact. 0.46. What is the ratio of the Internet users (% of population) of Serbia in 2007 to that in 2012?
Give a very brief answer. 0.69. What is the ratio of the Internet users (% of population) in Vietnam in 2007 to that in 2012?
Offer a very short reply. 0.53. What is the ratio of the Internet users (% of population) in Middle East & North Africa (developing only) in 2008 to that in 2009?
Your answer should be compact. 0.85. What is the ratio of the Internet users (% of population) of Serbia in 2008 to that in 2009?
Make the answer very short. 0.93. What is the ratio of the Internet users (% of population) in Vietnam in 2008 to that in 2009?
Provide a short and direct response. 0.9. What is the ratio of the Internet users (% of population) of Middle East & North Africa (developing only) in 2008 to that in 2010?
Your answer should be compact. 0.73. What is the ratio of the Internet users (% of population) in Serbia in 2008 to that in 2010?
Offer a very short reply. 0.87. What is the ratio of the Internet users (% of population) in Vietnam in 2008 to that in 2010?
Provide a short and direct response. 0.78. What is the ratio of the Internet users (% of population) of Middle East & North Africa (developing only) in 2008 to that in 2011?
Give a very brief answer. 0.66. What is the ratio of the Internet users (% of population) in Serbia in 2008 to that in 2011?
Give a very brief answer. 0.84. What is the ratio of the Internet users (% of population) in Vietnam in 2008 to that in 2011?
Give a very brief answer. 0.68. What is the ratio of the Internet users (% of population) of Middle East & North Africa (developing only) in 2008 to that in 2012?
Keep it short and to the point. 0.58. What is the ratio of the Internet users (% of population) in Serbia in 2008 to that in 2012?
Provide a short and direct response. 0.74. What is the ratio of the Internet users (% of population) of Vietnam in 2008 to that in 2012?
Your response must be concise. 0.61. What is the ratio of the Internet users (% of population) of Middle East & North Africa (developing only) in 2009 to that in 2010?
Your response must be concise. 0.86. What is the ratio of the Internet users (% of population) in Serbia in 2009 to that in 2010?
Your answer should be very brief. 0.93. What is the ratio of the Internet users (% of population) in Vietnam in 2009 to that in 2010?
Give a very brief answer. 0.87. What is the ratio of the Internet users (% of population) in Middle East & North Africa (developing only) in 2009 to that in 2011?
Provide a succinct answer. 0.78. What is the ratio of the Internet users (% of population) of Serbia in 2009 to that in 2011?
Your answer should be compact. 0.9. What is the ratio of the Internet users (% of population) of Vietnam in 2009 to that in 2011?
Provide a short and direct response. 0.76. What is the ratio of the Internet users (% of population) of Middle East & North Africa (developing only) in 2009 to that in 2012?
Keep it short and to the point. 0.69. What is the ratio of the Internet users (% of population) of Serbia in 2009 to that in 2012?
Your response must be concise. 0.79. What is the ratio of the Internet users (% of population) of Vietnam in 2009 to that in 2012?
Keep it short and to the point. 0.67. What is the ratio of the Internet users (% of population) in Middle East & North Africa (developing only) in 2010 to that in 2011?
Provide a succinct answer. 0.91. What is the ratio of the Internet users (% of population) in Serbia in 2010 to that in 2011?
Your response must be concise. 0.97. What is the ratio of the Internet users (% of population) of Vietnam in 2010 to that in 2011?
Give a very brief answer. 0.87. What is the ratio of the Internet users (% of population) in Middle East & North Africa (developing only) in 2010 to that in 2012?
Ensure brevity in your answer.  0.8. What is the ratio of the Internet users (% of population) in Serbia in 2010 to that in 2012?
Offer a terse response. 0.85. What is the ratio of the Internet users (% of population) of Vietnam in 2010 to that in 2012?
Provide a short and direct response. 0.78. What is the ratio of the Internet users (% of population) of Middle East & North Africa (developing only) in 2011 to that in 2012?
Provide a succinct answer. 0.88. What is the ratio of the Internet users (% of population) in Serbia in 2011 to that in 2012?
Provide a short and direct response. 0.88. What is the ratio of the Internet users (% of population) in Vietnam in 2011 to that in 2012?
Provide a short and direct response. 0.89. What is the difference between the highest and the second highest Internet users (% of population) in Middle East & North Africa (developing only)?
Your answer should be compact. 3.03. What is the difference between the highest and the second highest Internet users (% of population) in Serbia?
Keep it short and to the point. 5.9. What is the difference between the highest and the second highest Internet users (% of population) of Vietnam?
Give a very brief answer. 4.42. What is the difference between the highest and the lowest Internet users (% of population) in Middle East & North Africa (developing only)?
Offer a very short reply. 17.25. What is the difference between the highest and the lowest Internet users (% of population) in Serbia?
Ensure brevity in your answer.  21.8. What is the difference between the highest and the lowest Internet users (% of population) of Vietnam?
Your answer should be very brief. 26.75. 